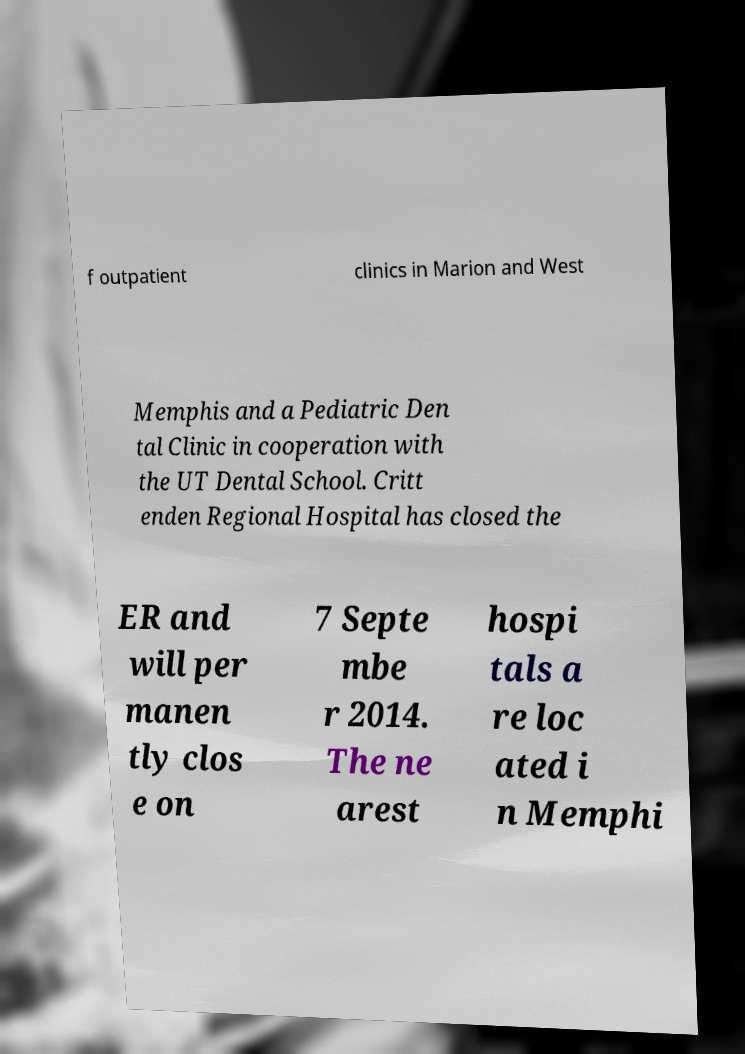Please identify and transcribe the text found in this image. f outpatient clinics in Marion and West Memphis and a Pediatric Den tal Clinic in cooperation with the UT Dental School. Critt enden Regional Hospital has closed the ER and will per manen tly clos e on 7 Septe mbe r 2014. The ne arest hospi tals a re loc ated i n Memphi 